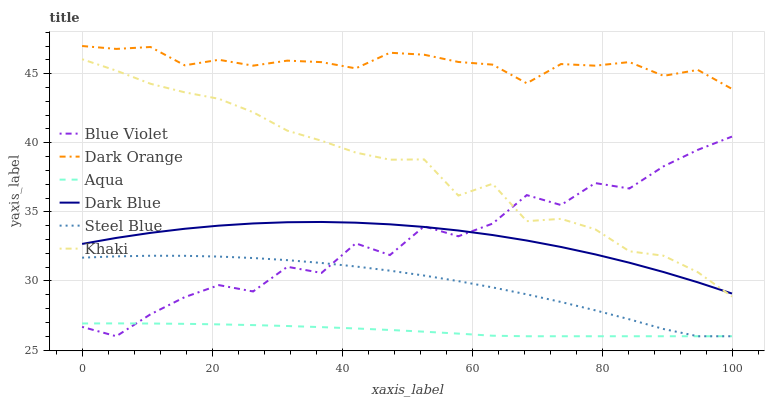Does Aqua have the minimum area under the curve?
Answer yes or no. Yes. Does Dark Orange have the maximum area under the curve?
Answer yes or no. Yes. Does Khaki have the minimum area under the curve?
Answer yes or no. No. Does Khaki have the maximum area under the curve?
Answer yes or no. No. Is Aqua the smoothest?
Answer yes or no. Yes. Is Blue Violet the roughest?
Answer yes or no. Yes. Is Khaki the smoothest?
Answer yes or no. No. Is Khaki the roughest?
Answer yes or no. No. Does Aqua have the lowest value?
Answer yes or no. Yes. Does Khaki have the lowest value?
Answer yes or no. No. Does Dark Orange have the highest value?
Answer yes or no. Yes. Does Khaki have the highest value?
Answer yes or no. No. Is Steel Blue less than Khaki?
Answer yes or no. Yes. Is Dark Orange greater than Steel Blue?
Answer yes or no. Yes. Does Blue Violet intersect Aqua?
Answer yes or no. Yes. Is Blue Violet less than Aqua?
Answer yes or no. No. Is Blue Violet greater than Aqua?
Answer yes or no. No. Does Steel Blue intersect Khaki?
Answer yes or no. No. 